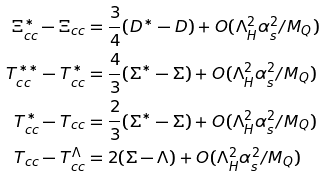Convert formula to latex. <formula><loc_0><loc_0><loc_500><loc_500>\Xi _ { c c } ^ { * } - \Xi _ { c c } & = \frac { 3 } { 4 } ( D ^ { * } - D ) + O ( \Lambda _ { H } ^ { 2 } \alpha _ { s } ^ { 2 } / M _ { Q } ) \\ T _ { c c } ^ { * * } - T _ { c c } ^ { * } & = \frac { 4 } { 3 } ( \Sigma ^ { * } - \Sigma ) + O ( \Lambda _ { H } ^ { 2 } \alpha _ { s } ^ { 2 } / M _ { Q } ) \\ T _ { c c } ^ { * } - T _ { c c } & = \frac { 2 } { 3 } ( \Sigma ^ { * } - \Sigma ) + O ( \Lambda _ { H } ^ { 2 } \alpha _ { s } ^ { 2 } / M _ { Q } ) \\ T _ { c c } - T _ { c c } ^ { \Lambda } & = 2 ( \Sigma - \Lambda ) + O ( \Lambda _ { H } ^ { 2 } \alpha _ { s } ^ { 2 } / M _ { Q } )</formula> 